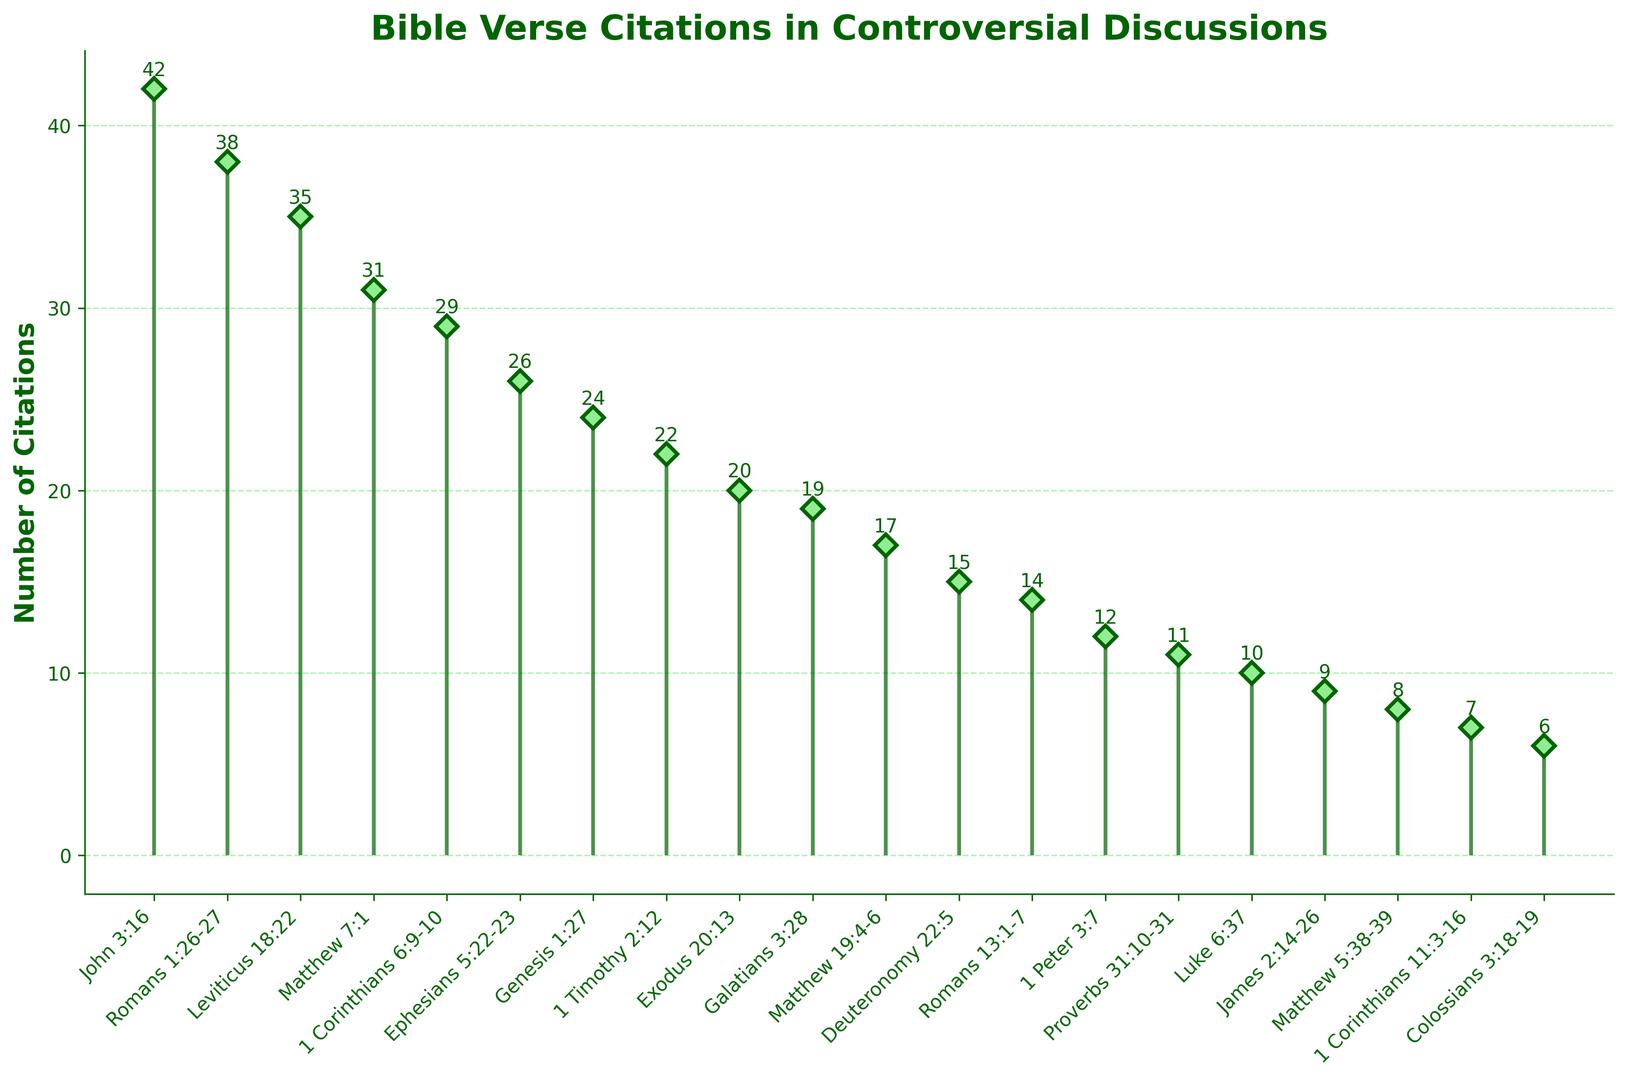What is the most cited Bible verse? The most cited Bible verse is the one with the highest stem. In the plot, it’s John 3:16 with 42 citations.
Answer: John 3:16 Which verse has the second-highest number of citations? By looking at the second tallest stem, we can see that Romans 1:26-27 is the second most cited with 38 citations.
Answer: Romans 1:26-27 What is the combined number of citations for verses from the book of Matthew? Add up the citations for all the listed verses from Matthew: Matthew 7:1 (31), Matthew 19:4-6 (17), and Matthew 5:38-39 (8). The combined number is 31 + 17 + 8 = 56.
Answer: 56 Are there any verses that have the same number of citations? By examining the plot, no two stems appear to have the same height, which means no verses have the same number of citations.
Answer: No Which book of the Bible is cited the least frequently, according to the plot? The shortest stem indicates the least frequently cited verse. Colossians 3:18-19 is cited only 6 times, making Colossians the least frequently cited book in the plot.
Answer: Colossians Which verse has more citations: 1 Corinthians 6:9-10 or Romans 13:1-7? Compare the heights of the stems for these verses. 1 Corinthians 6:9-10 has 29 citations, while Romans 13:1-7 has 14 citations. Thus, 1 Corinthians 6:9-10 has more.
Answer: 1 Corinthians 6:9-10 What is the average number of citations for the listed verses? To find the average, sum all citations and divide by the number of verses: (42 + 38 + 35 + 31 + 29 + 26 + 24 + 22 + 20 + 19 + 17 + 15 + 14 + 12 + 11 + 10 + 9 + 8 + 7 + 6) / 20. The sum is 375, and the number of verses is 20, so the average is 375 / 20 = 18.75.
Answer: 18.75 How many verses have more than 20 citations? By counting the stems taller than the height at 20 citations, we find that 8 verses have more than 20 citations.
Answer: 8 Which verse from the New Testament is cited just below Leviticus 18:22? The verses from the New Testament with citations close to Leviticus 18:22 (35 citations) are Matthew 7:1 (31 citations). Therefore, Matthew 7:1 is cited just below it.
Answer: Matthew 7:1 What is the total number of citations for verses from the Pauline epistles? Sum the citations for all the listed verses from the Pauline epistles: Romans 1:26-27 (38), 1 Corinthians 6:9-10 (29), Ephesians 5:22-23 (26), Romans 13:1-7 (14), and Colossians 3:18-19 (6). The total is 38 + 29 + 26 + 14 + 6 = 113.
Answer: 113 